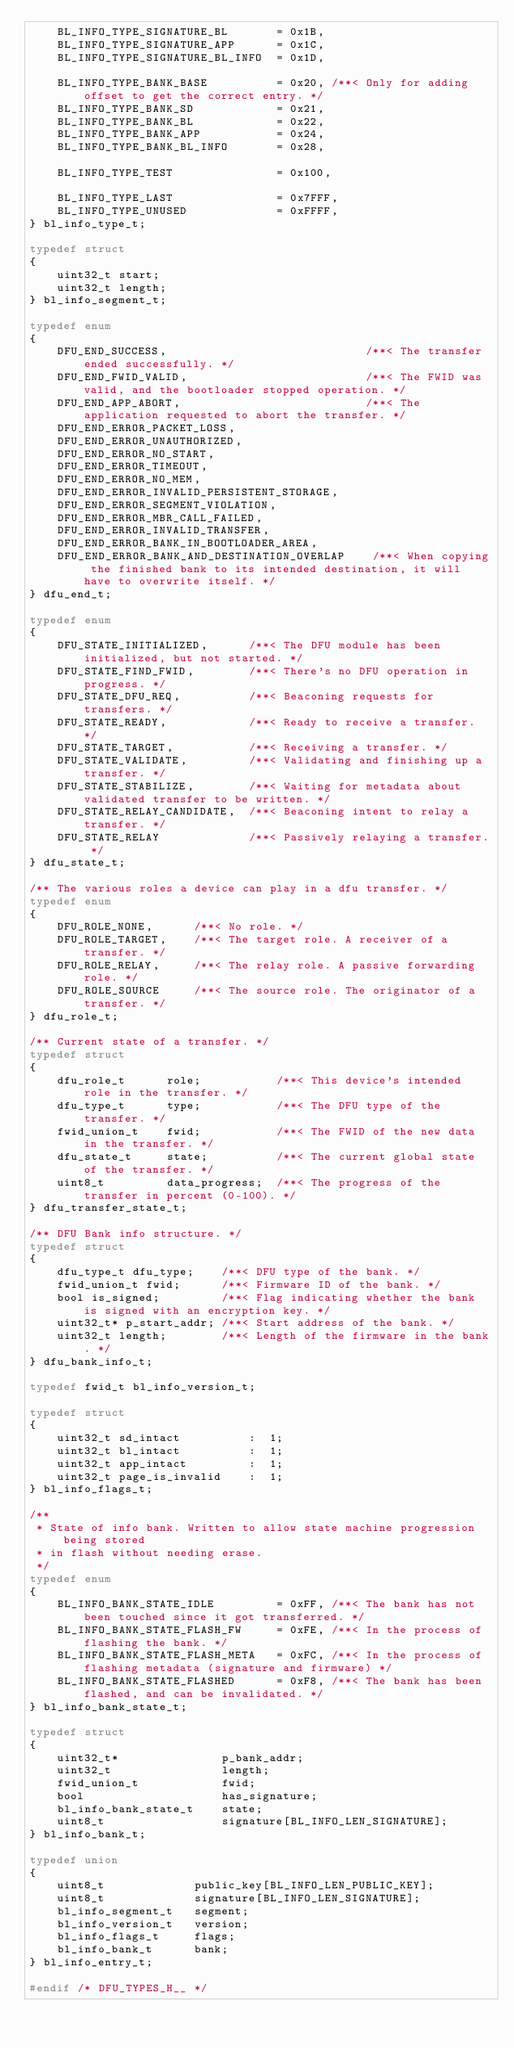<code> <loc_0><loc_0><loc_500><loc_500><_C_>    BL_INFO_TYPE_SIGNATURE_BL       = 0x1B,
    BL_INFO_TYPE_SIGNATURE_APP      = 0x1C,
    BL_INFO_TYPE_SIGNATURE_BL_INFO  = 0x1D,

    BL_INFO_TYPE_BANK_BASE          = 0x20, /**< Only for adding offset to get the correct entry. */
    BL_INFO_TYPE_BANK_SD            = 0x21,
    BL_INFO_TYPE_BANK_BL            = 0x22,
    BL_INFO_TYPE_BANK_APP           = 0x24,
    BL_INFO_TYPE_BANK_BL_INFO       = 0x28,

    BL_INFO_TYPE_TEST               = 0x100,

    BL_INFO_TYPE_LAST               = 0x7FFF,
    BL_INFO_TYPE_UNUSED             = 0xFFFF,
} bl_info_type_t;

typedef struct
{
    uint32_t start;
    uint32_t length;
} bl_info_segment_t;

typedef enum
{
    DFU_END_SUCCESS,                             /**< The transfer ended successfully. */
    DFU_END_FWID_VALID,                          /**< The FWID was valid, and the bootloader stopped operation. */
    DFU_END_APP_ABORT,                           /**< The application requested to abort the transfer. */
    DFU_END_ERROR_PACKET_LOSS,
    DFU_END_ERROR_UNAUTHORIZED,
    DFU_END_ERROR_NO_START,
    DFU_END_ERROR_TIMEOUT,
    DFU_END_ERROR_NO_MEM,
    DFU_END_ERROR_INVALID_PERSISTENT_STORAGE,
    DFU_END_ERROR_SEGMENT_VIOLATION,
    DFU_END_ERROR_MBR_CALL_FAILED,
    DFU_END_ERROR_INVALID_TRANSFER,
    DFU_END_ERROR_BANK_IN_BOOTLOADER_AREA,
    DFU_END_ERROR_BANK_AND_DESTINATION_OVERLAP    /**< When copying the finished bank to its intended destination, it will have to overwrite itself. */
} dfu_end_t;

typedef enum
{
    DFU_STATE_INITIALIZED,      /**< The DFU module has been initialized, but not started. */
    DFU_STATE_FIND_FWID,        /**< There's no DFU operation in progress. */
    DFU_STATE_DFU_REQ,          /**< Beaconing requests for transfers. */
    DFU_STATE_READY,            /**< Ready to receive a transfer. */
    DFU_STATE_TARGET,           /**< Receiving a transfer. */
    DFU_STATE_VALIDATE,         /**< Validating and finishing up a transfer. */
    DFU_STATE_STABILIZE,        /**< Waiting for metadata about validated transfer to be written. */
    DFU_STATE_RELAY_CANDIDATE,  /**< Beaconing intent to relay a transfer. */
    DFU_STATE_RELAY             /**< Passively relaying a transfer. */
} dfu_state_t;

/** The various roles a device can play in a dfu transfer. */
typedef enum
{
    DFU_ROLE_NONE,      /**< No role. */
    DFU_ROLE_TARGET,    /**< The target role. A receiver of a transfer. */
    DFU_ROLE_RELAY,     /**< The relay role. A passive forwarding role. */
    DFU_ROLE_SOURCE     /**< The source role. The originator of a transfer. */
} dfu_role_t;

/** Current state of a transfer. */
typedef struct
{
    dfu_role_t      role;           /**< This device's intended role in the transfer. */
    dfu_type_t      type;           /**< The DFU type of the transfer. */
    fwid_union_t    fwid;           /**< The FWID of the new data in the transfer. */
    dfu_state_t     state;          /**< The current global state of the transfer. */
    uint8_t         data_progress;  /**< The progress of the transfer in percent (0-100). */
} dfu_transfer_state_t;

/** DFU Bank info structure. */
typedef struct
{
    dfu_type_t dfu_type;    /**< DFU type of the bank. */
    fwid_union_t fwid;      /**< Firmware ID of the bank. */
    bool is_signed;         /**< Flag indicating whether the bank is signed with an encryption key. */
    uint32_t* p_start_addr; /**< Start address of the bank. */
    uint32_t length;        /**< Length of the firmware in the bank. */
} dfu_bank_info_t;

typedef fwid_t bl_info_version_t;

typedef struct
{
    uint32_t sd_intact          :  1;
    uint32_t bl_intact          :  1;
    uint32_t app_intact         :  1;
    uint32_t page_is_invalid    :  1;
} bl_info_flags_t;

/**
 * State of info bank. Written to allow state machine progression being stored
 * in flash without needing erase.
 */
typedef enum
{
    BL_INFO_BANK_STATE_IDLE         = 0xFF, /**< The bank has not been touched since it got transferred. */
    BL_INFO_BANK_STATE_FLASH_FW     = 0xFE, /**< In the process of flashing the bank. */
    BL_INFO_BANK_STATE_FLASH_META   = 0xFC, /**< In the process of flashing metadata (signature and firmware) */
    BL_INFO_BANK_STATE_FLASHED      = 0xF8, /**< The bank has been flashed, and can be invalidated. */
} bl_info_bank_state_t;

typedef struct
{
    uint32_t*               p_bank_addr;
    uint32_t                length;
    fwid_union_t            fwid;
    bool                    has_signature;
    bl_info_bank_state_t    state;
    uint8_t                 signature[BL_INFO_LEN_SIGNATURE];
} bl_info_bank_t;

typedef union
{
    uint8_t             public_key[BL_INFO_LEN_PUBLIC_KEY];
    uint8_t             signature[BL_INFO_LEN_SIGNATURE];
    bl_info_segment_t   segment;
    bl_info_version_t   version;
    bl_info_flags_t     flags;
    bl_info_bank_t      bank;
} bl_info_entry_t;

#endif /* DFU_TYPES_H__ */
</code> 